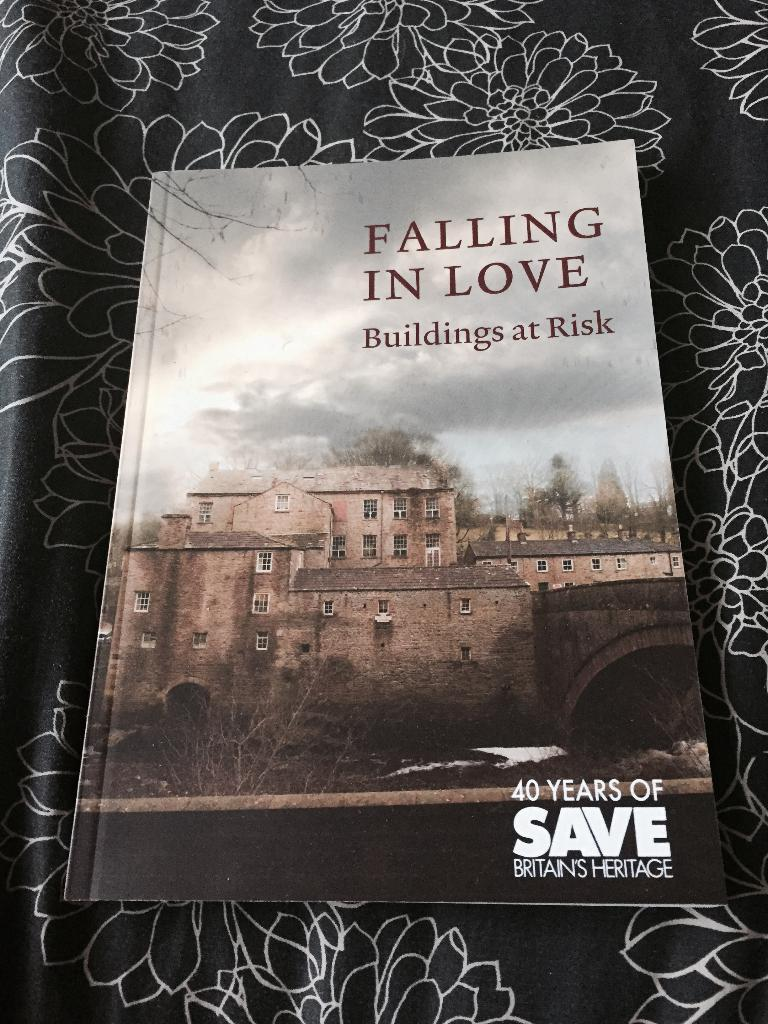<image>
Give a short and clear explanation of the subsequent image. A book about buildings at risk sits on a black and white cloth. 